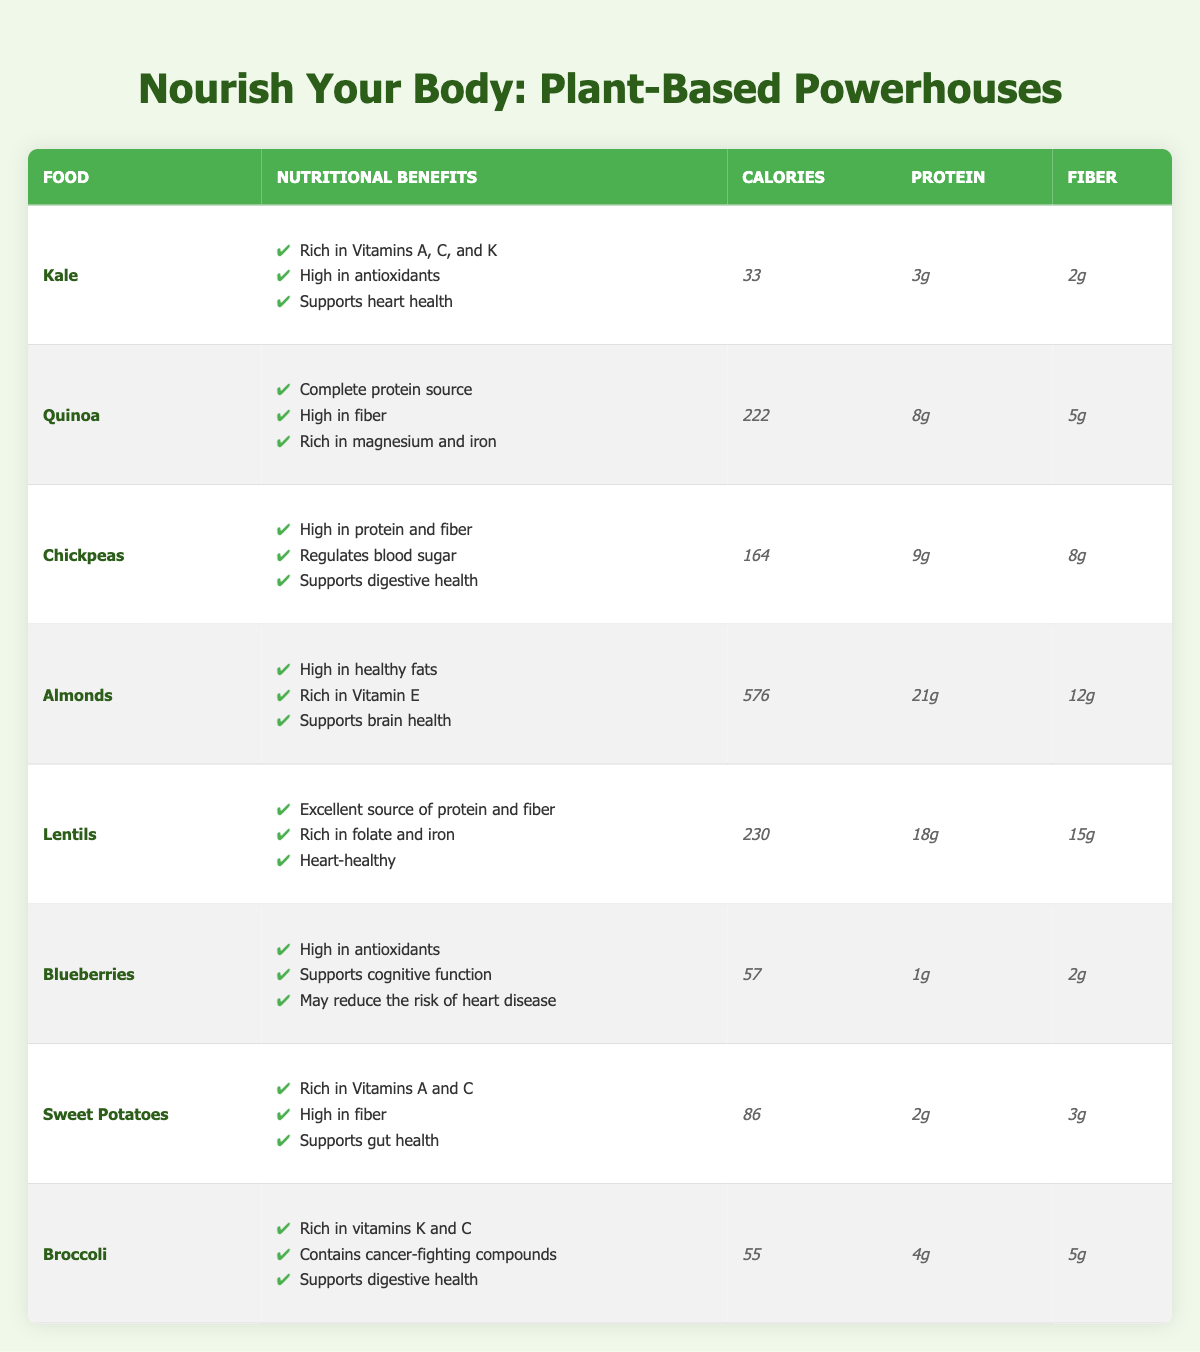What are the nutritional benefits of Kale? The table lists the nutritional benefits of Kale, which are: Rich in Vitamins A, C, and K; High in antioxidants; Supports heart health.
Answer: Rich in Vitamins A, C, and K; High in antioxidants; Supports heart health Which food has the highest protein content? Looking at the protein content column, Almonds have 21g of protein, which is more than any other food listed in the table.
Answer: Almonds How many calories are in Lentils? The table directly indicates that the calorie count for Lentils is 230.
Answer: 230 Is Broccoli high in fiber? By checking the fiber column, Broccoli shows that it has 5g of fiber, which is a moderate amount but not as high as some other foods in the table. So yes, it is considered high in fiber.
Answer: Yes What is the average calorie content of the plant-based foods listed? First, we add up the calories of all foods: 33 + 222 + 164 + 576 + 230 + 57 + 86 + 55 = 1,423. Then, divide by the number of foods, which is 8. 1,423 / 8 = 177.875, which we can round down if needed.
Answer: Approximately 178 Do Sweet Potatoes have high protein content? In the table, Sweet Potatoes are listed with a protein content of 2g, which is low compared to other plant-based foods. Therefore, they do not have high protein content.
Answer: No Which food has the highest fiber content? Observing the fiber column, Lentils have 15g of fiber, which is the highest amount listed in the table when compared to all other foods.
Answer: Lentils Does Quinoa provide a complete protein source? The table states that Quinoa is a complete protein source, indicating that it contains all essential amino acids required for human health.
Answer: Yes 